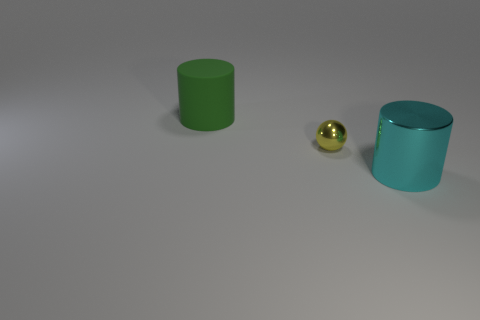Add 2 large brown spheres. How many objects exist? 5 Subtract all cyan cylinders. How many cylinders are left? 1 Subtract all cylinders. How many objects are left? 1 Subtract all cyan cylinders. Subtract all purple balls. How many cylinders are left? 1 Subtract all blue cylinders. How many red spheres are left? 0 Subtract all large rubber things. Subtract all tiny yellow objects. How many objects are left? 1 Add 1 matte things. How many matte things are left? 2 Add 2 small objects. How many small objects exist? 3 Subtract 0 purple blocks. How many objects are left? 3 